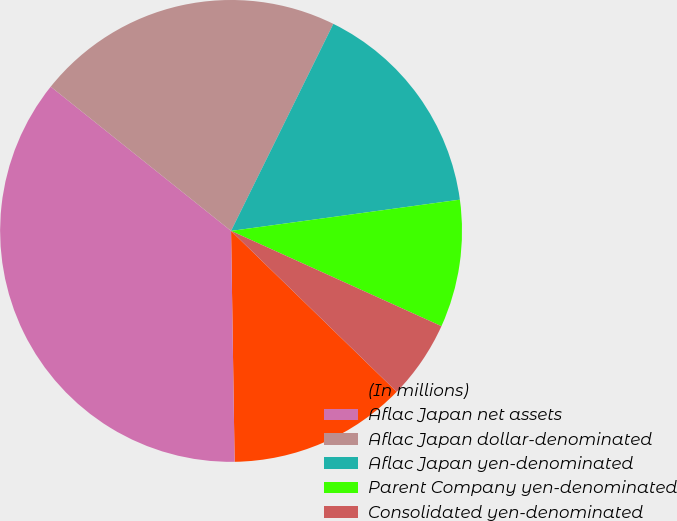Convert chart to OTSL. <chart><loc_0><loc_0><loc_500><loc_500><pie_chart><fcel>(In millions)<fcel>Aflac Japan net assets<fcel>Aflac Japan dollar-denominated<fcel>Aflac Japan yen-denominated<fcel>Parent Company yen-denominated<fcel>Consolidated yen-denominated<nl><fcel>12.49%<fcel>35.99%<fcel>21.57%<fcel>15.54%<fcel>8.93%<fcel>5.5%<nl></chart> 